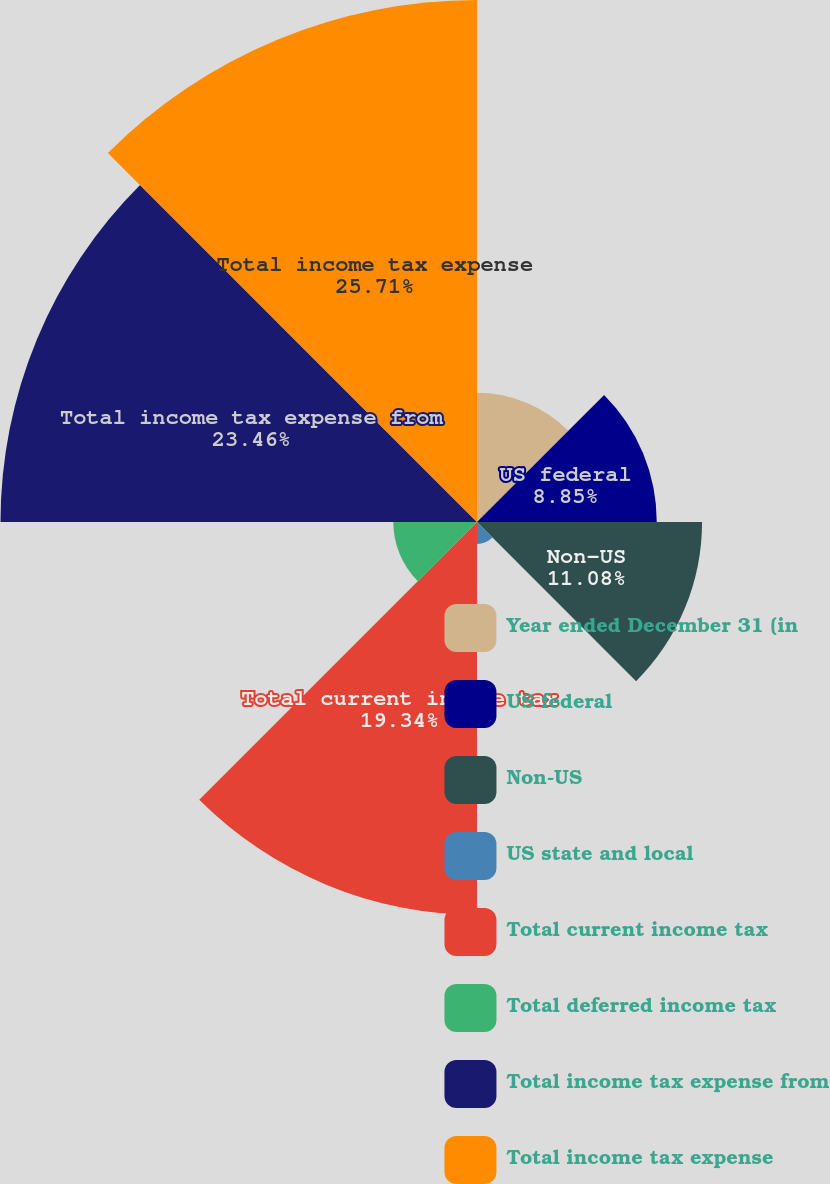<chart> <loc_0><loc_0><loc_500><loc_500><pie_chart><fcel>Year ended December 31 (in<fcel>US federal<fcel>Non-US<fcel>US state and local<fcel>Total current income tax<fcel>Total deferred income tax<fcel>Total income tax expense from<fcel>Total income tax expense<nl><fcel>6.36%<fcel>8.85%<fcel>11.08%<fcel>1.08%<fcel>19.34%<fcel>4.12%<fcel>23.46%<fcel>25.7%<nl></chart> 